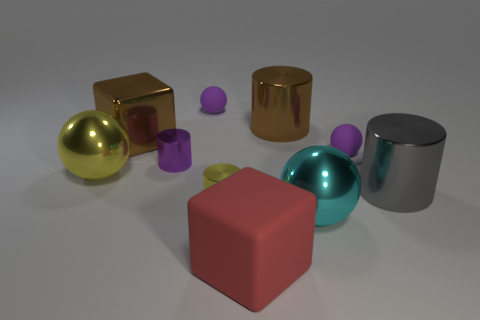There is a thing that is the same color as the big shiny cube; what material is it?
Keep it short and to the point. Metal. What is the color of the large cube that is to the left of the rubber block that is on the right side of the large shiny ball that is on the left side of the large metal cube?
Make the answer very short. Brown. What is the shape of the yellow object on the left side of the large brown block?
Provide a short and direct response. Sphere. There is a small yellow object that is the same material as the yellow ball; what is its shape?
Offer a terse response. Cylinder. Is there anything else that has the same shape as the tiny yellow object?
Make the answer very short. Yes. How many brown cylinders are in front of the cyan shiny ball?
Provide a short and direct response. 0. Are there an equal number of small spheres to the left of the purple cylinder and tiny gray rubber objects?
Keep it short and to the point. Yes. Is the material of the yellow cylinder the same as the large cyan object?
Keep it short and to the point. Yes. How big is the shiny object that is both in front of the gray metal cylinder and on the right side of the yellow cylinder?
Your response must be concise. Large. What number of other spheres have the same size as the yellow metallic sphere?
Your response must be concise. 1. 